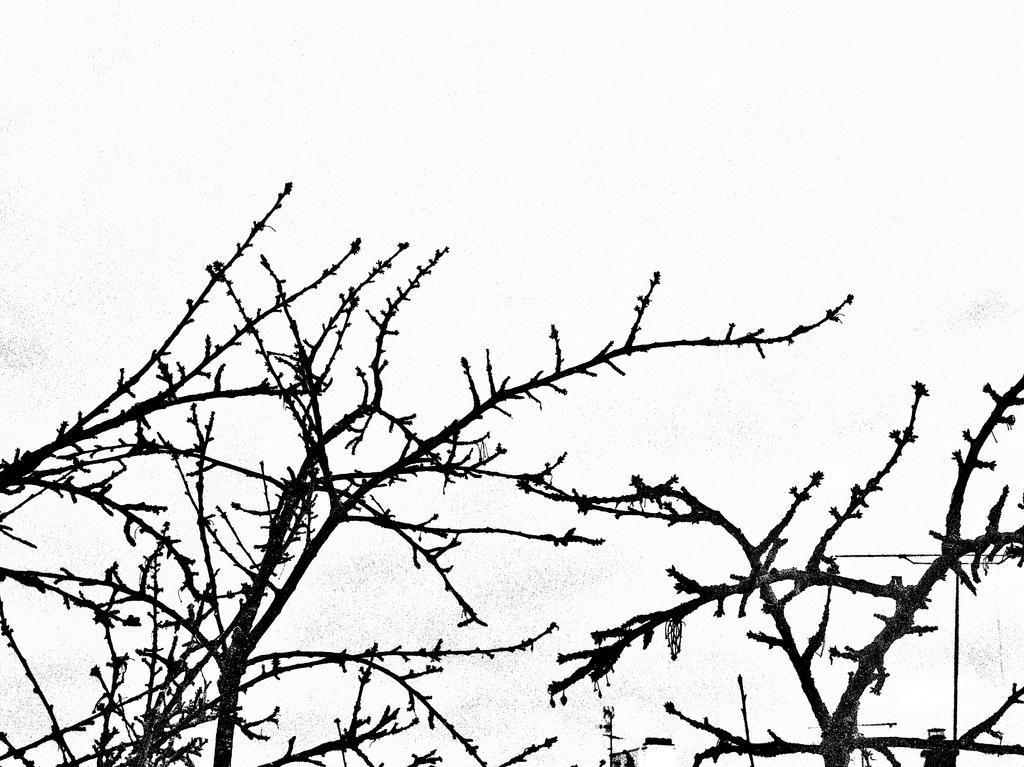Can you describe this image briefly? This image consists of a dry tree. In the background, there is a sky. 